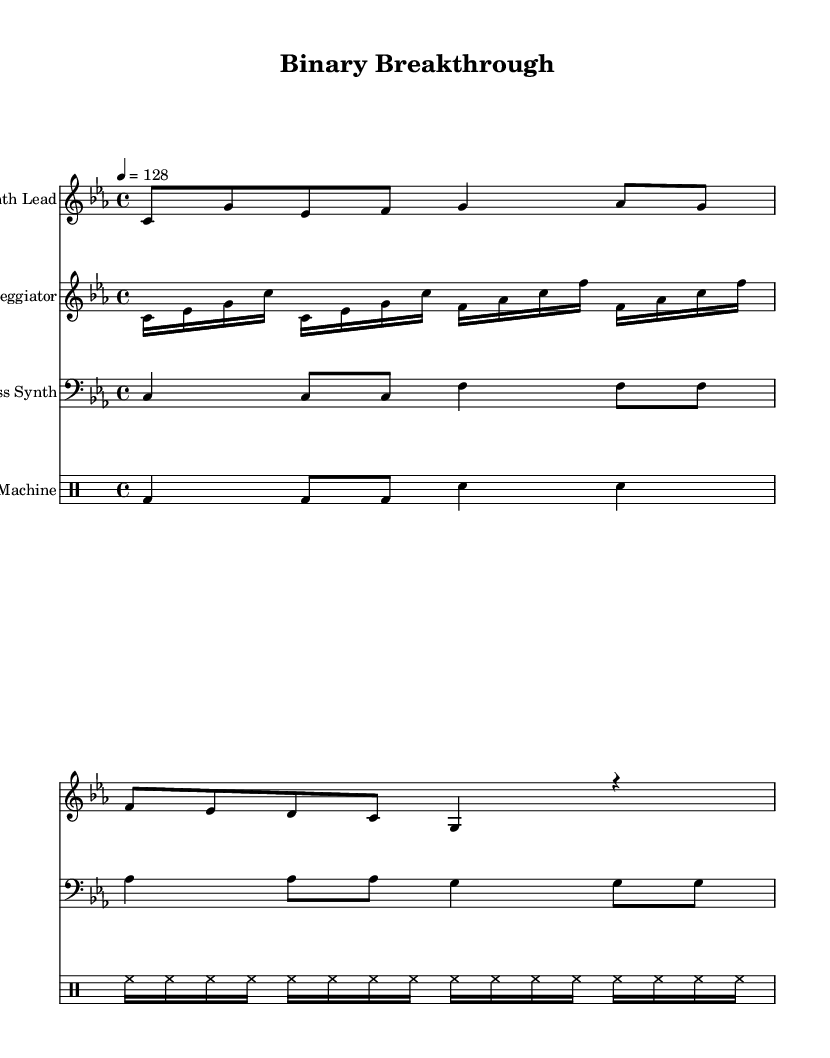What is the key signature of this music? The key signature is indicated at the beginning of the music, showing three flats. It specifies the key of C minor.
Answer: C minor What is the time signature of this piece? The time signature is shown at the beginning of the music, indicating four beats per measure, which is represented as 4/4.
Answer: 4/4 What is the tempo of the piece? The tempo marking indicates the speed of the music, which is set at 128 beats per minute, as shown by the tempo notation.
Answer: 128 How many measures are in the Synth Lead section? Counting the measures in the Synth Lead staff indicates there are a total of three distinct measures.
Answer: 3 Which instrument has the lowest range? By examining the notation and clef on the staff, the Bass Synth is written in the bass clef, which generally represents lower pitches compared to other staves.
Answer: Bass Synth What rhythmic pattern do the Drum Machine and Synth Lead share? Analyzing the rhythm reveals that both the Drum Machine and Synth Lead utilize eighth notes, which contribute to the overall groove of the electronic piece.
Answer: Eighth notes What type of electronic element is primarily featured in the arpeggiator part? The arpeggiator is characterized by rapid, sequential notes that create a flowing texture commonly found in electronic music, indicated by the repeated sixteenth notes.
Answer: Sequential notes 